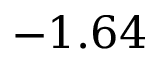<formula> <loc_0><loc_0><loc_500><loc_500>- 1 . 6 4</formula> 